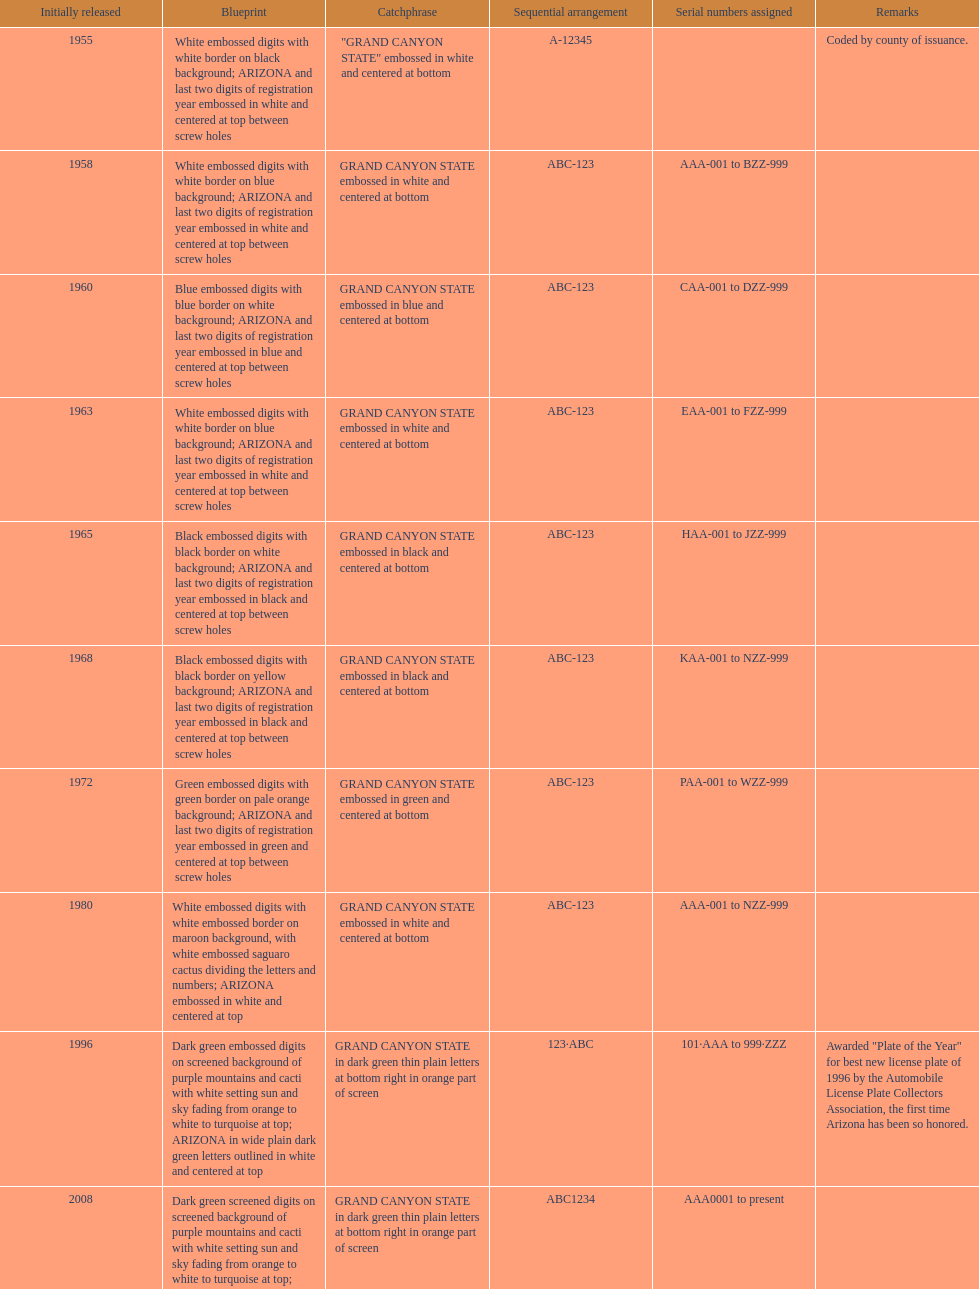Which year featured the license plate with the least characters? 1955. 